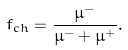Convert formula to latex. <formula><loc_0><loc_0><loc_500><loc_500>f _ { c h } = \frac { \mu ^ { - } } { \mu ^ { - } + \mu ^ { + } } .</formula> 